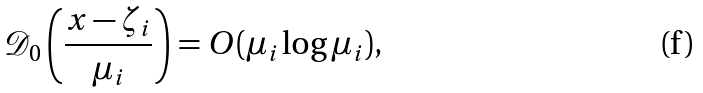<formula> <loc_0><loc_0><loc_500><loc_500>\mathcal { D } _ { 0 } \left ( \frac { x - \zeta _ { i } } { \mu _ { i } } \right ) = O ( \mu _ { i } \log \mu _ { i } ) ,</formula> 